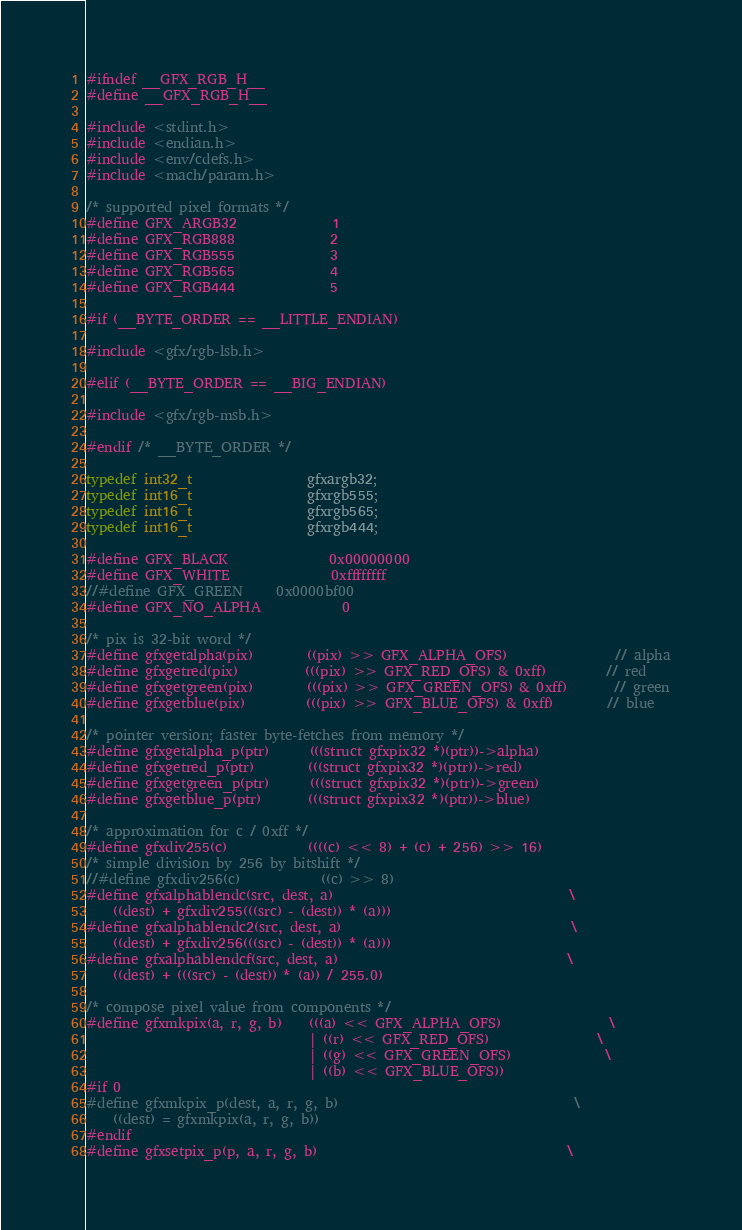<code> <loc_0><loc_0><loc_500><loc_500><_C_>#ifndef __GFX_RGB_H__
#define __GFX_RGB_H__

#include <stdint.h>
#include <endian.h>
#include <env/cdefs.h>
#include <mach/param.h>

/* supported pixel formats */
#define GFX_ARGB32              1
#define GFX_RGB888              2
#define GFX_RGB555              3
#define GFX_RGB565              4
#define GFX_RGB444              5

#if (__BYTE_ORDER == __LITTLE_ENDIAN)

#include <gfx/rgb-lsb.h>

#elif (__BYTE_ORDER == __BIG_ENDIAN)

#include <gfx/rgb-msb.h>

#endif /* __BYTE_ORDER */

typedef int32_t                 gfxargb32;
typedef int16_t                 gfxrgb555;
typedef int16_t                 gfxrgb565;
typedef int16_t                 gfxrgb444;

#define GFX_BLACK               0x00000000
#define GFX_WHITE               0xffffffff
//#define GFX_GREEN     0x0000bf00
#define GFX_NO_ALPHA            0

/* pix is 32-bit word */
#define gfxgetalpha(pix)        ((pix) >> GFX_ALPHA_OFS)                // alpha
#define gfxgetred(pix)          (((pix) >> GFX_RED_OFS) & 0xff)         // red
#define gfxgetgreen(pix)        (((pix) >> GFX_GREEN_OFS) & 0xff)       // green
#define gfxgetblue(pix)         (((pix) >> GFX_BLUE_OFS) & 0xff)        // blue

/* pointer version; faster byte-fetches from memory */
#define gfxgetalpha_p(ptr)      (((struct gfxpix32 *)(ptr))->alpha)
#define gfxgetred_p(ptr)        (((struct gfxpix32 *)(ptr))->red)
#define gfxgetgreen_p(ptr)      (((struct gfxpix32 *)(ptr))->green)
#define gfxgetblue_p(ptr)       (((struct gfxpix32 *)(ptr))->blue)

/* approximation for c / 0xff */
#define gfxdiv255(c)            ((((c) << 8) + (c) + 256) >> 16)
/* simple division by 256 by bitshift */
//#define gfxdiv256(c)            ((c) >> 8)
#define gfxalphablendc(src, dest, a)                                   \
    ((dest) + gfxdiv255(((src) - (dest)) * (a)))
#define gfxalphablendc2(src, dest, a)                                  \
    ((dest) + gfxdiv256(((src) - (dest)) * (a)))
#define gfxalphablendcf(src, dest, a)                                  \
    ((dest) + (((src) - (dest)) * (a)) / 255.0)

/* compose pixel value from components */
#define gfxmkpix(a, r, g, b)    (((a) << GFX_ALPHA_OFS)                \
                                 | ((r) << GFX_RED_OFS)                \
                                 | ((g) << GFX_GREEN_OFS)              \
                                 | ((b) << GFX_BLUE_OFS))
#if 0
#define gfxmkpix_p(dest, a, r, g, b)                                   \
    ((dest) = gfxmkpix(a, r, g, b))
#endif
#define gfxsetpix_p(p, a, r, g, b)                                     \</code> 